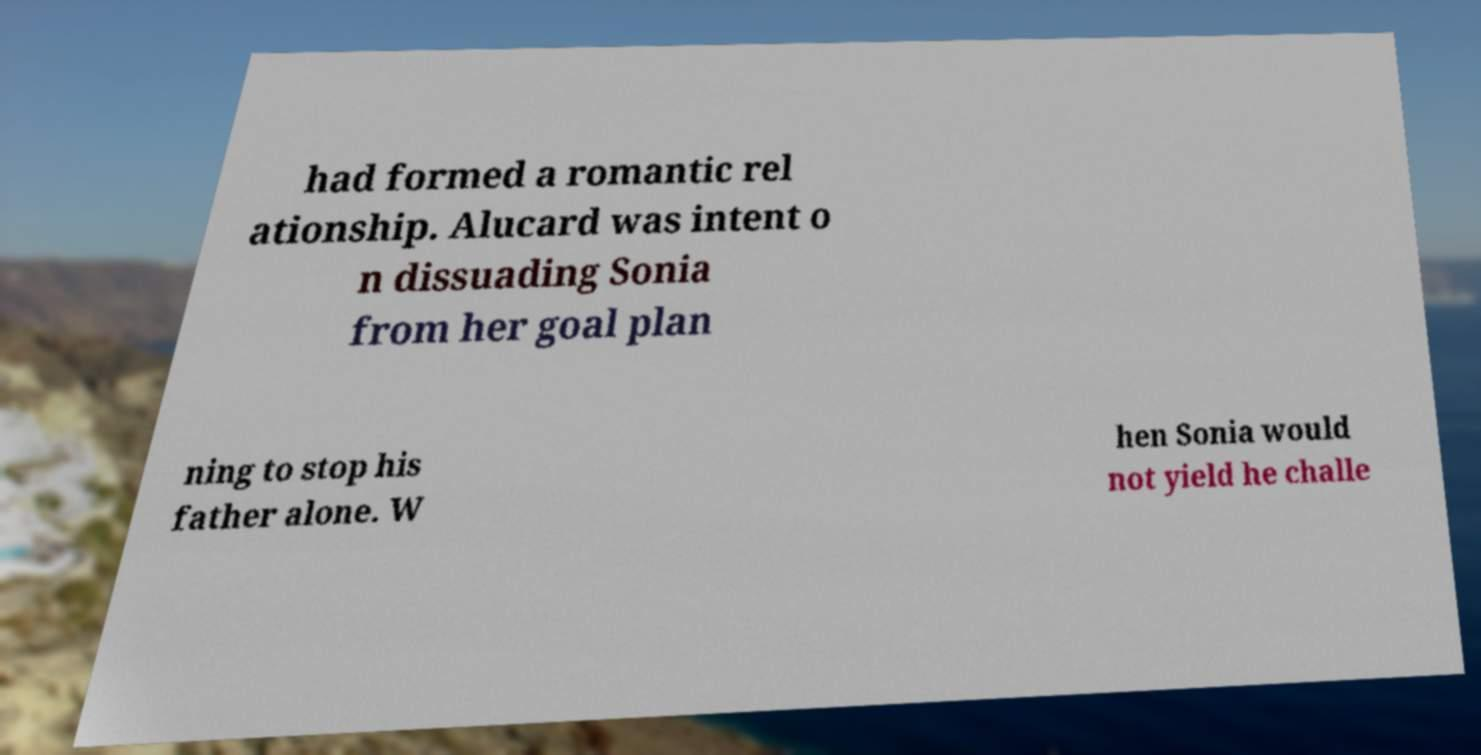What messages or text are displayed in this image? I need them in a readable, typed format. had formed a romantic rel ationship. Alucard was intent o n dissuading Sonia from her goal plan ning to stop his father alone. W hen Sonia would not yield he challe 